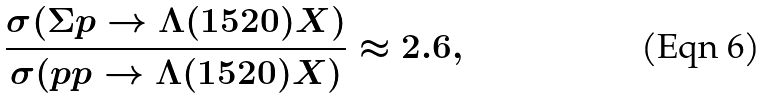Convert formula to latex. <formula><loc_0><loc_0><loc_500><loc_500>\frac { \sigma ( \Sigma p \to \Lambda ( 1 5 2 0 ) X ) } { \sigma ( p p \to \Lambda ( 1 5 2 0 ) X ) } \approx 2 . 6 ,</formula> 